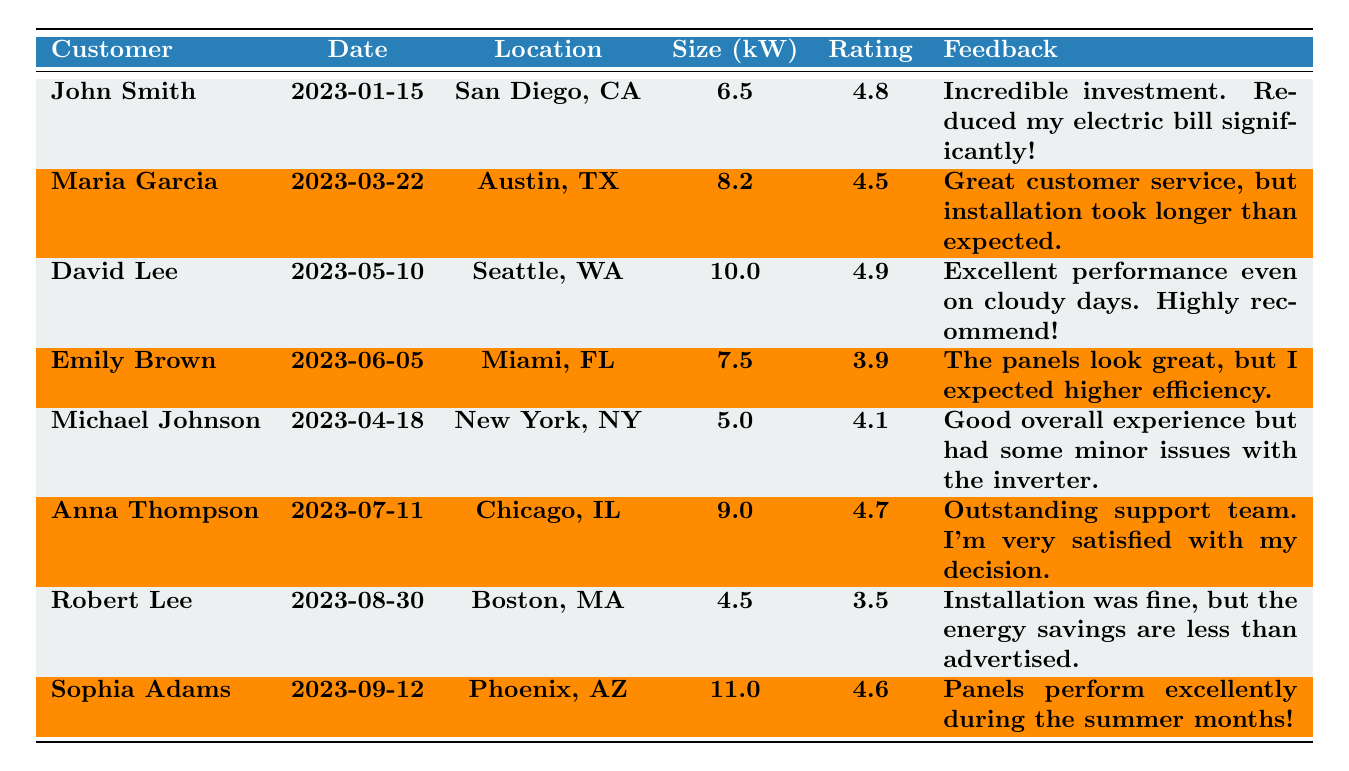What is the highest satisfaction rating among the customers? The highest satisfaction rating in the table is 4.9, which is associated with David Lee.
Answer: 4.9 Who has the lowest satisfaction rating? The lowest satisfaction rating in the table is 3.5, which is for Robert Lee.
Answer: Robert Lee How many customers rated their satisfaction above 4.5? There are five customers who rated their satisfaction above 4.5: John Smith, David Lee, Anna Thompson, Sophia Adams, and Maria Garcia.
Answer: 5 What is the average satisfaction rating of all the customers? To find the average, sum up all the ratings (4.8 + 4.5 + 4.9 + 3.9 + 4.1 + 4.7 + 3.5 + 4.6 = 36.0) and divide by the number of ratings (8). So, the average rating is 36.0 / 8 = 4.5.
Answer: 4.5 Did any customer provide feedback on installation time? Yes, Maria Garcia mentioned that the installation took longer than expected.
Answer: Yes Which customer has the largest solar panel system size? The largest solar panel system size is 11.0 kW, which is for Sophia Adams.
Answer: Sophia Adams Is there any customer who expressed dissatisfaction about the energy savings? Yes, Robert Lee stated that the energy savings are less than advertised.
Answer: Yes How does the satisfaction rating of Emily Brown compare to the average rating? Emily Brown's rating is 3.9, which is below the average rating of 4.5.
Answer: Below average What is the total system size of all installations? The total system size is calculated by summing up all the individual sizes (6.5 + 8.2 + 10.0 + 7.5 + 5.0 + 9.0 + 4.5 + 11.0 = 58.7 kW).
Answer: 58.7 kW Which city has the highest-rated customer's feedback? Looking at the ratings, David Lee from Seattle, WA has the highest satisfaction rating of 4.9.
Answer: Seattle, WA 